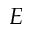Convert formula to latex. <formula><loc_0><loc_0><loc_500><loc_500>E</formula> 